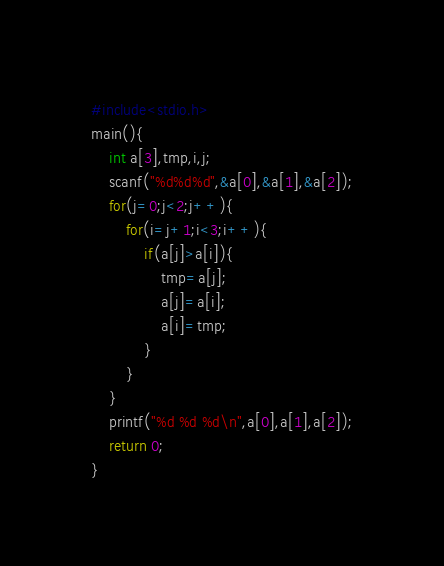<code> <loc_0><loc_0><loc_500><loc_500><_C_>#include<stdio.h>
main(){
	int a[3],tmp,i,j;
	scanf("%d%d%d",&a[0],&a[1],&a[2]);
	for(j=0;j<2;j++){
		for(i=j+1;i<3;i++){
			if(a[j]>a[i]){
				tmp=a[j];
				a[j]=a[i];
				a[i]=tmp;
			}
		}
	}
	printf("%d %d %d\n",a[0],a[1],a[2]);
	return 0;
}</code> 